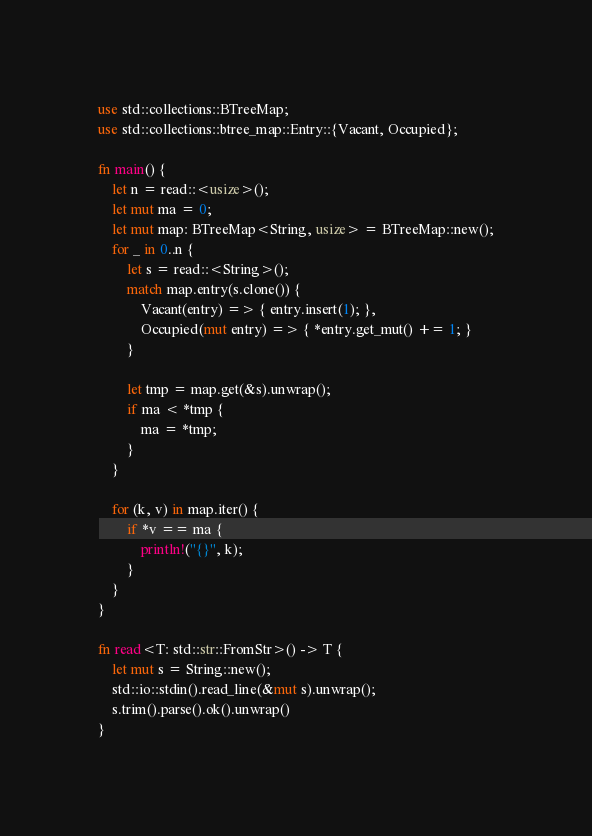Convert code to text. <code><loc_0><loc_0><loc_500><loc_500><_Rust_>use std::collections::BTreeMap;
use std::collections::btree_map::Entry::{Vacant, Occupied};

fn main() {
    let n = read::<usize>();
    let mut ma = 0;
    let mut map: BTreeMap<String, usize> = BTreeMap::new();
    for _ in 0..n {
        let s = read::<String>();
        match map.entry(s.clone()) {
            Vacant(entry) => { entry.insert(1); },
            Occupied(mut entry) => { *entry.get_mut() += 1; }
        }

        let tmp = map.get(&s).unwrap();
        if ma < *tmp {
            ma = *tmp;
        }
    }

    for (k, v) in map.iter() {
        if *v == ma {
            println!("{}", k);
        }
    }
}

fn read<T: std::str::FromStr>() -> T {
    let mut s = String::new();
    std::io::stdin().read_line(&mut s).unwrap();
    s.trim().parse().ok().unwrap()
}
</code> 